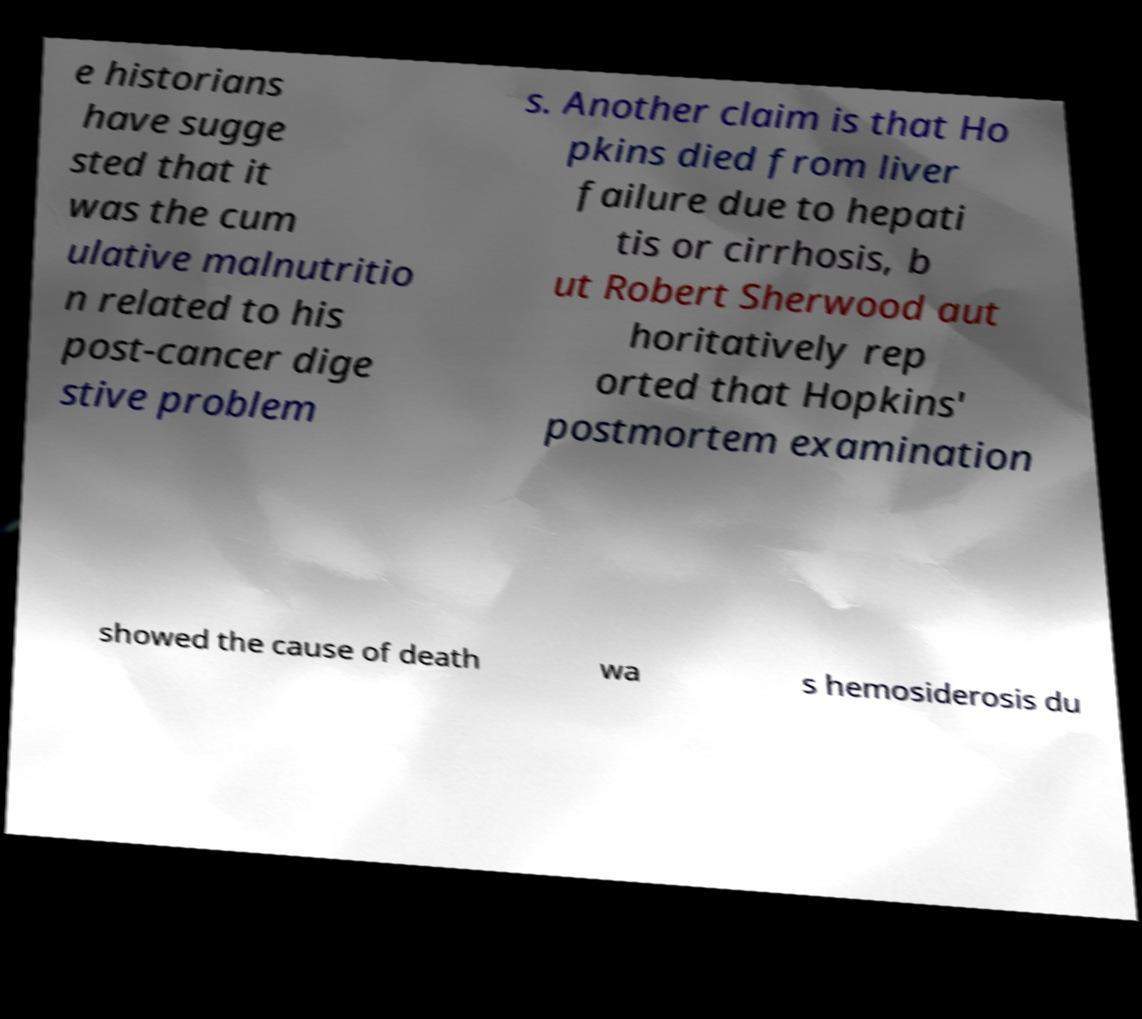Can you accurately transcribe the text from the provided image for me? e historians have sugge sted that it was the cum ulative malnutritio n related to his post-cancer dige stive problem s. Another claim is that Ho pkins died from liver failure due to hepati tis or cirrhosis, b ut Robert Sherwood aut horitatively rep orted that Hopkins' postmortem examination showed the cause of death wa s hemosiderosis du 